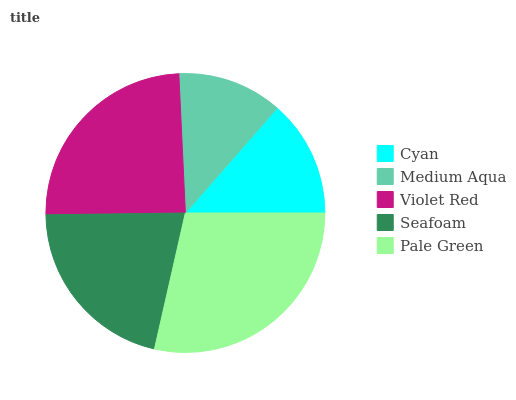Is Medium Aqua the minimum?
Answer yes or no. Yes. Is Pale Green the maximum?
Answer yes or no. Yes. Is Violet Red the minimum?
Answer yes or no. No. Is Violet Red the maximum?
Answer yes or no. No. Is Violet Red greater than Medium Aqua?
Answer yes or no. Yes. Is Medium Aqua less than Violet Red?
Answer yes or no. Yes. Is Medium Aqua greater than Violet Red?
Answer yes or no. No. Is Violet Red less than Medium Aqua?
Answer yes or no. No. Is Seafoam the high median?
Answer yes or no. Yes. Is Seafoam the low median?
Answer yes or no. Yes. Is Cyan the high median?
Answer yes or no. No. Is Violet Red the low median?
Answer yes or no. No. 